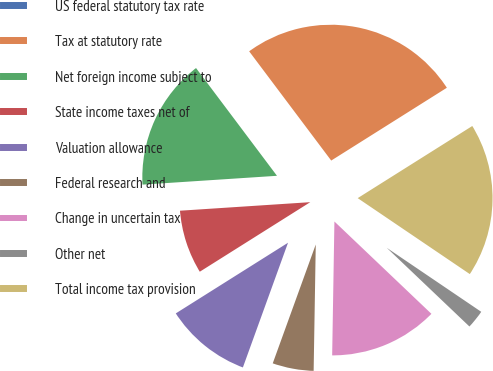Convert chart to OTSL. <chart><loc_0><loc_0><loc_500><loc_500><pie_chart><fcel>US federal statutory tax rate<fcel>Tax at statutory rate<fcel>Net foreign income subject to<fcel>State income taxes net of<fcel>Valuation allowance<fcel>Federal research and<fcel>Change in uncertain tax<fcel>Other net<fcel>Total income tax provision<nl><fcel>0.0%<fcel>26.31%<fcel>15.79%<fcel>7.9%<fcel>10.53%<fcel>5.26%<fcel>13.16%<fcel>2.63%<fcel>18.42%<nl></chart> 